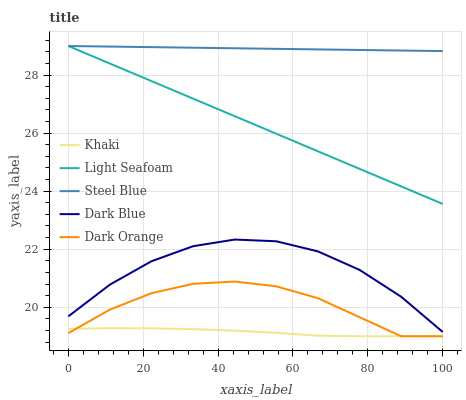Does Khaki have the minimum area under the curve?
Answer yes or no. Yes. Does Steel Blue have the maximum area under the curve?
Answer yes or no. Yes. Does Steel Blue have the minimum area under the curve?
Answer yes or no. No. Does Khaki have the maximum area under the curve?
Answer yes or no. No. Is Light Seafoam the smoothest?
Answer yes or no. Yes. Is Dark Blue the roughest?
Answer yes or no. Yes. Is Khaki the smoothest?
Answer yes or no. No. Is Khaki the roughest?
Answer yes or no. No. Does Khaki have the lowest value?
Answer yes or no. Yes. Does Steel Blue have the lowest value?
Answer yes or no. No. Does Light Seafoam have the highest value?
Answer yes or no. Yes. Does Khaki have the highest value?
Answer yes or no. No. Is Dark Orange less than Dark Blue?
Answer yes or no. Yes. Is Steel Blue greater than Khaki?
Answer yes or no. Yes. Does Steel Blue intersect Light Seafoam?
Answer yes or no. Yes. Is Steel Blue less than Light Seafoam?
Answer yes or no. No. Is Steel Blue greater than Light Seafoam?
Answer yes or no. No. Does Dark Orange intersect Dark Blue?
Answer yes or no. No. 